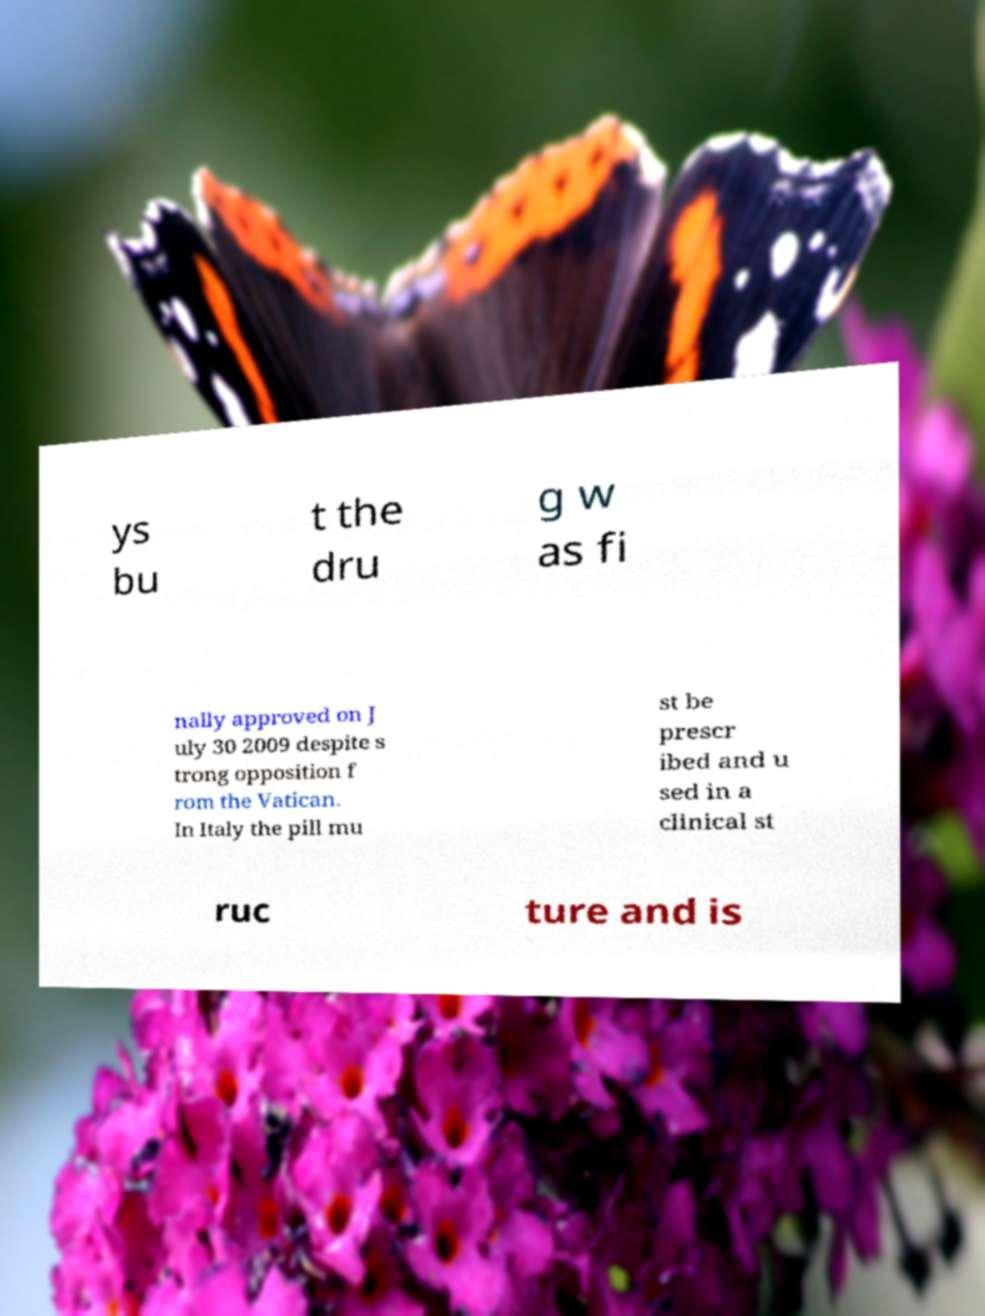Could you extract and type out the text from this image? ys bu t the dru g w as fi nally approved on J uly 30 2009 despite s trong opposition f rom the Vatican. In Italy the pill mu st be prescr ibed and u sed in a clinical st ruc ture and is 